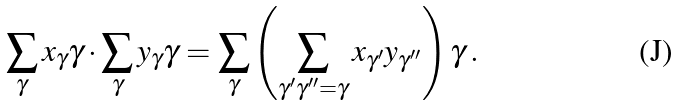<formula> <loc_0><loc_0><loc_500><loc_500>\sum _ { \gamma } x _ { \gamma } \gamma \cdot \sum _ { \gamma } y _ { \gamma } \gamma = \sum _ { \gamma } \left ( \sum _ { \gamma ^ { \prime } \gamma ^ { \prime \prime } = \gamma } x _ { \gamma ^ { \prime } } y _ { \gamma ^ { \prime \prime } } \right ) \gamma \, .</formula> 